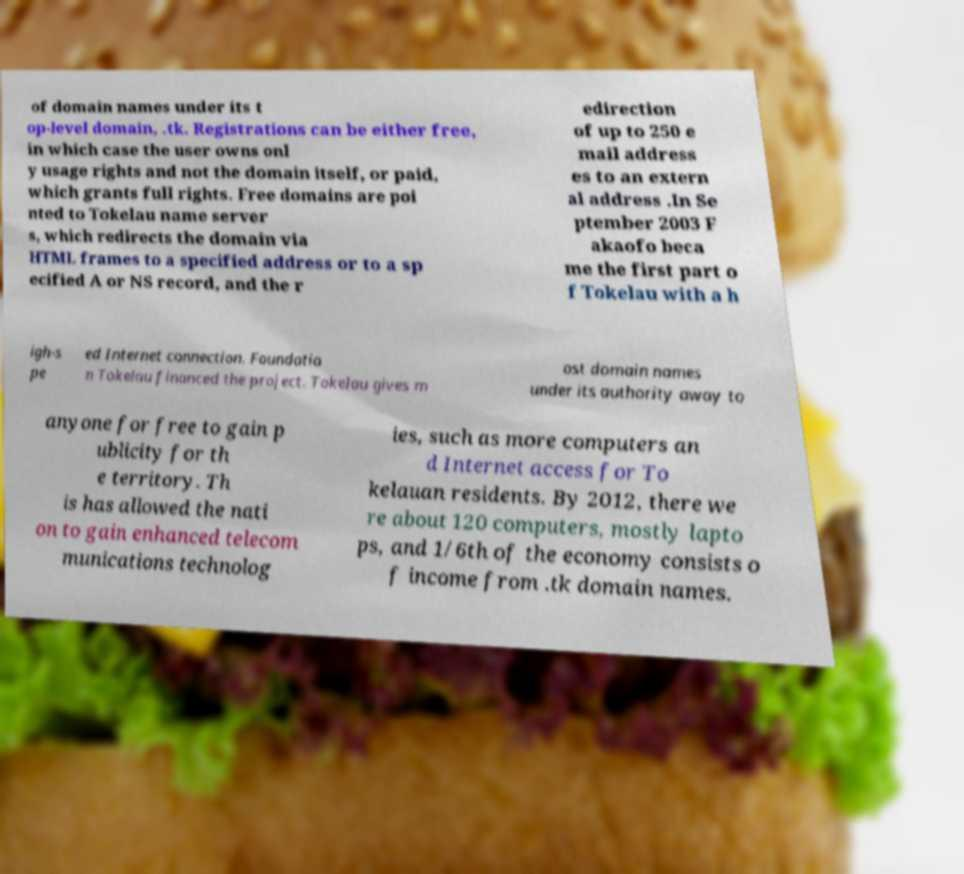Could you extract and type out the text from this image? of domain names under its t op-level domain, .tk. Registrations can be either free, in which case the user owns onl y usage rights and not the domain itself, or paid, which grants full rights. Free domains are poi nted to Tokelau name server s, which redirects the domain via HTML frames to a specified address or to a sp ecified A or NS record, and the r edirection of up to 250 e mail address es to an extern al address .In Se ptember 2003 F akaofo beca me the first part o f Tokelau with a h igh-s pe ed Internet connection. Foundatio n Tokelau financed the project. Tokelau gives m ost domain names under its authority away to anyone for free to gain p ublicity for th e territory. Th is has allowed the nati on to gain enhanced telecom munications technolog ies, such as more computers an d Internet access for To kelauan residents. By 2012, there we re about 120 computers, mostly lapto ps, and 1/6th of the economy consists o f income from .tk domain names. 